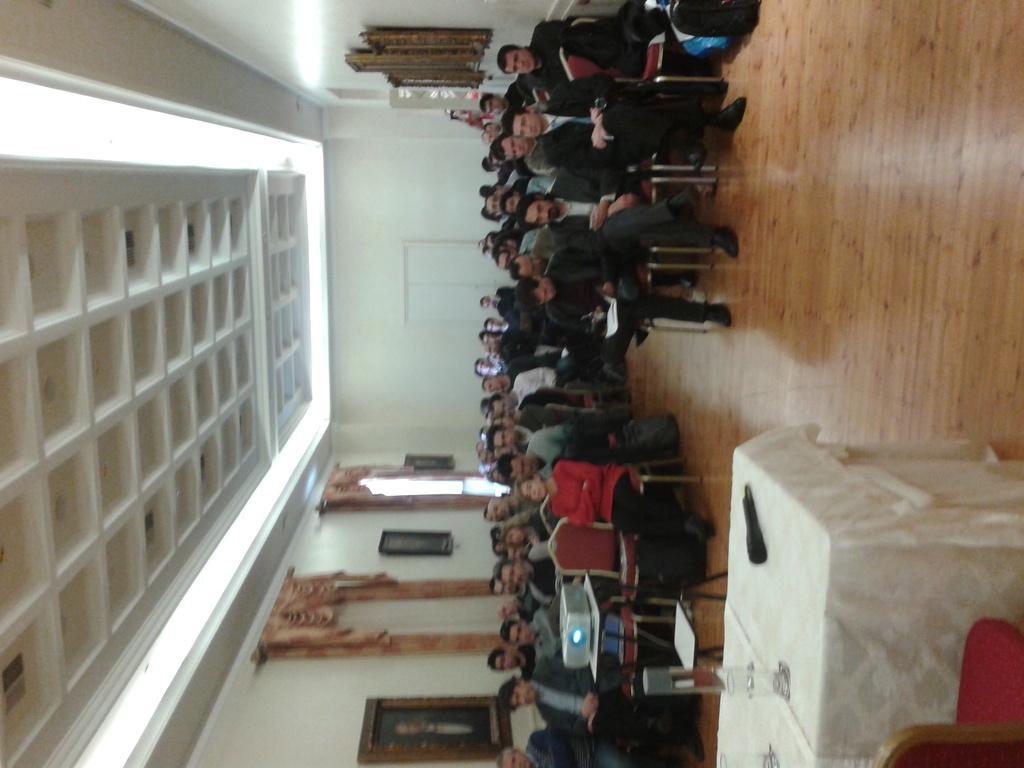How would you summarize this image in a sentence or two? In this image there are chairs and tables on the floor. There are people sitting on the chairs. There is a projector on the table. Right bottom there is a chair. Before it there is a table having glasses, mike. There are picture frames attached to the wall having doors. Lights are attached to the roof. 